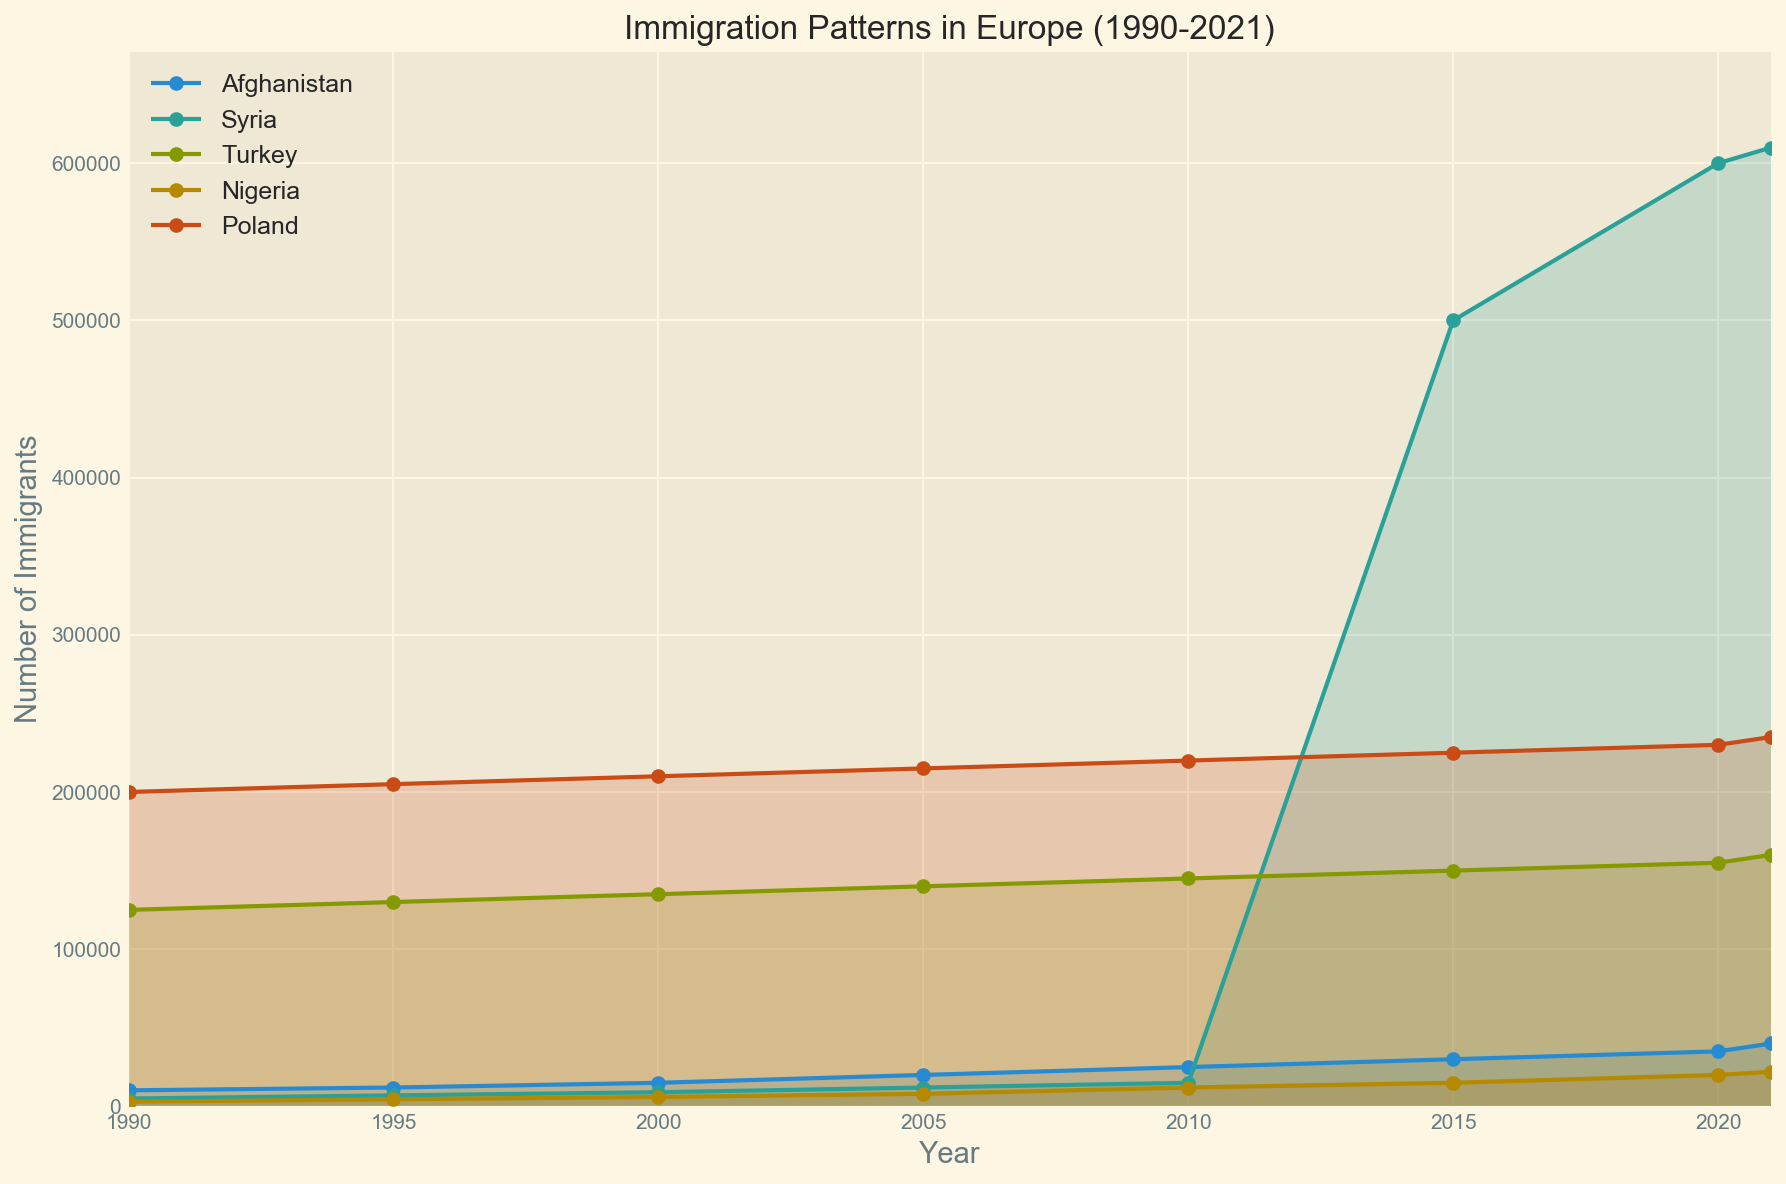Which country had the highest number of immigrants in 2021? By examining the height of the filled areas and the lines, it is evident that Syria had the highest number of immigrants in 2021, as the line representing Syria is the highest at that point.
Answer: Syria How did the immigration pattern from Afghanistan change between 1990 and 2021? The number of immigrants from Afghanistan consistently increased over time. It started at 10,200 in 1990 and rose to 40,000 by 2021, as shown by the ascending line in the plot.
Answer: Increased What is the difference in the number of immigrants from Syria between 2010 and 2015? The figure shows that in 2010, Syria had 15,000 immigrants and in 2015, it had 500,000. The difference is calculated as 500,000 - 15,000, which equals 485,000.
Answer: 485,000 Which country shows the most significant increase in the number of immigrants between 1990 and 2021? By comparing the slopes of the lines for each country, Syria shows the most significant increase, as the line's steepness between these years is the greatest for Syria.
Answer: Syria In which year did Nigeria first surpass 10,000 immigrants? Observing the line representing Nigeria, it first crosses the 10,000 mark in 2010.
Answer: 2010 By how much did Poland's number of immigrants increase from 1990 to 2021? Poland had 200,000 immigrants in 1990 and 235,000 in 2021. The increase is calculated as 235,000 - 200,000 = 35,000.
Answer: 35,000 Which two countries had almost parallel trends in immigration numbers from 1990 to 2021? The lines representing Turkey and Poland show almost parallel trends throughout the period, indicating similar patterns in their immigration numbers.
Answer: Turkey and Poland Between 2000 and 2010, which country saw the highest increase in the number of immigrants, and by how much? Syria saw the highest increase. In 2000, Syria had 9,000 immigrants, and by 2010, it had 15,000. The increase is 15,000 - 9,000 = 6,000.
Answer: Syria, 6,000 What is the overall trend in the number of immigrants from Nigeria between 1990 and 2021? The immigration numbers from Nigeria show a gradual upward trend from 1990 (3,000) to 2021 (22,000), with steady increases over the years.
Answer: Upward trend 